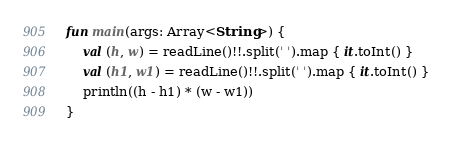<code> <loc_0><loc_0><loc_500><loc_500><_Kotlin_>fun main(args: Array<String>) {
    val (h, w) = readLine()!!.split(' ').map { it.toInt() }
    val (h1, w1) = readLine()!!.split(' ').map { it.toInt() }
    println((h - h1) * (w - w1))
}
</code> 